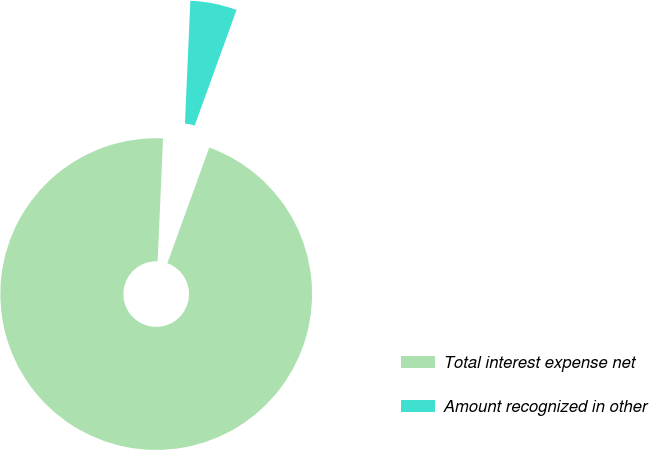Convert chart to OTSL. <chart><loc_0><loc_0><loc_500><loc_500><pie_chart><fcel>Total interest expense net<fcel>Amount recognized in other<nl><fcel>95.17%<fcel>4.83%<nl></chart> 